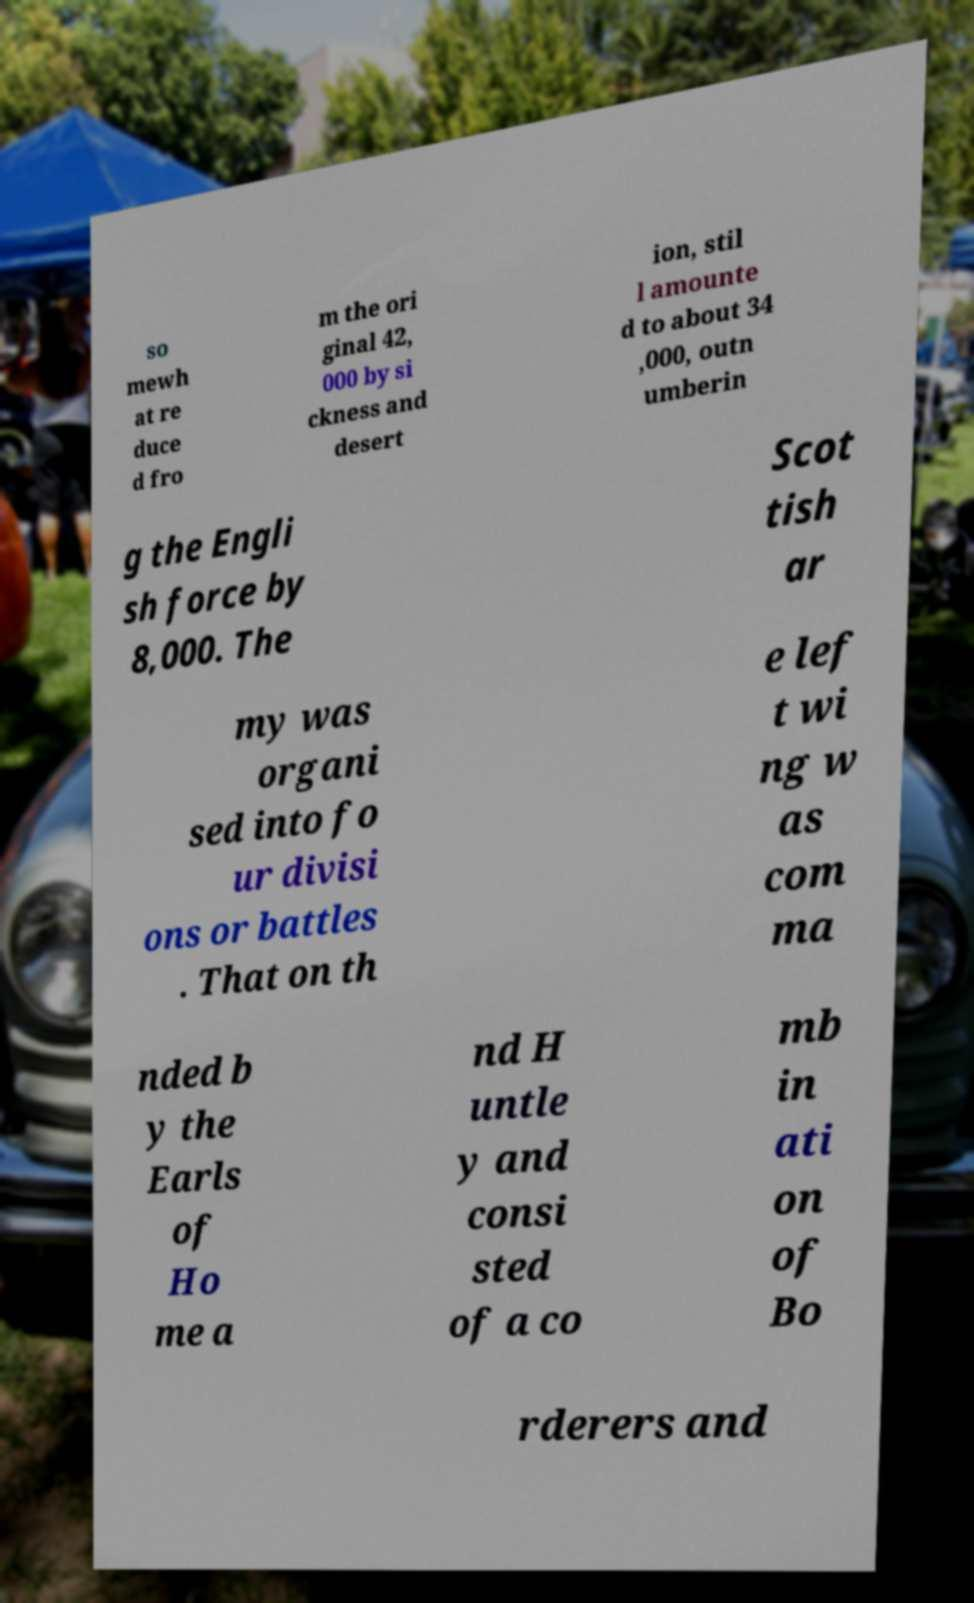Please identify and transcribe the text found in this image. so mewh at re duce d fro m the ori ginal 42, 000 by si ckness and desert ion, stil l amounte d to about 34 ,000, outn umberin g the Engli sh force by 8,000. The Scot tish ar my was organi sed into fo ur divisi ons or battles . That on th e lef t wi ng w as com ma nded b y the Earls of Ho me a nd H untle y and consi sted of a co mb in ati on of Bo rderers and 